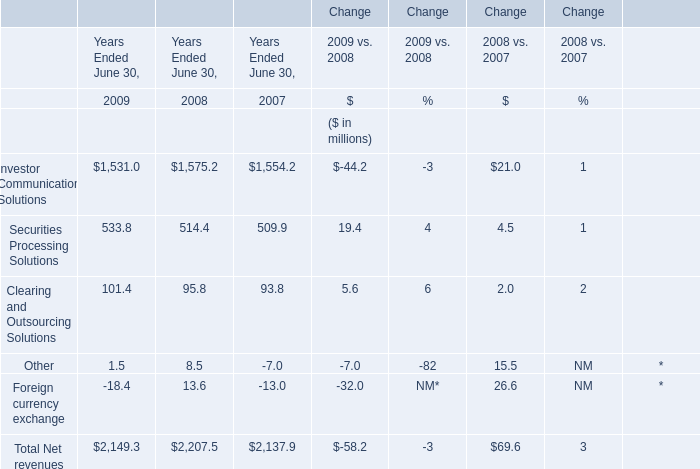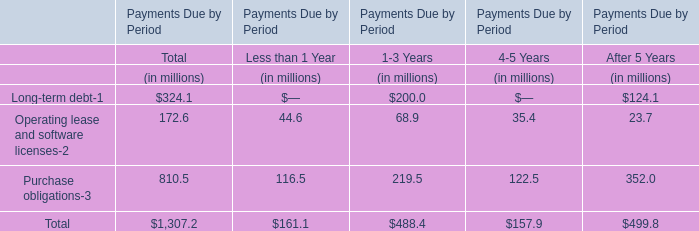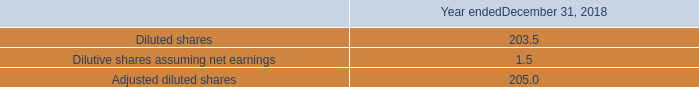what was the percentage change in cash flows used in investing activities from 2017 to 2018? 
Computations: ((416.6 - 510.8) / 510.8)
Answer: -0.18442. 